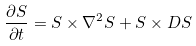Convert formula to latex. <formula><loc_0><loc_0><loc_500><loc_500>\frac { \partial S } { \partial t } = S \times \nabla ^ { 2 } S + S \times D S</formula> 